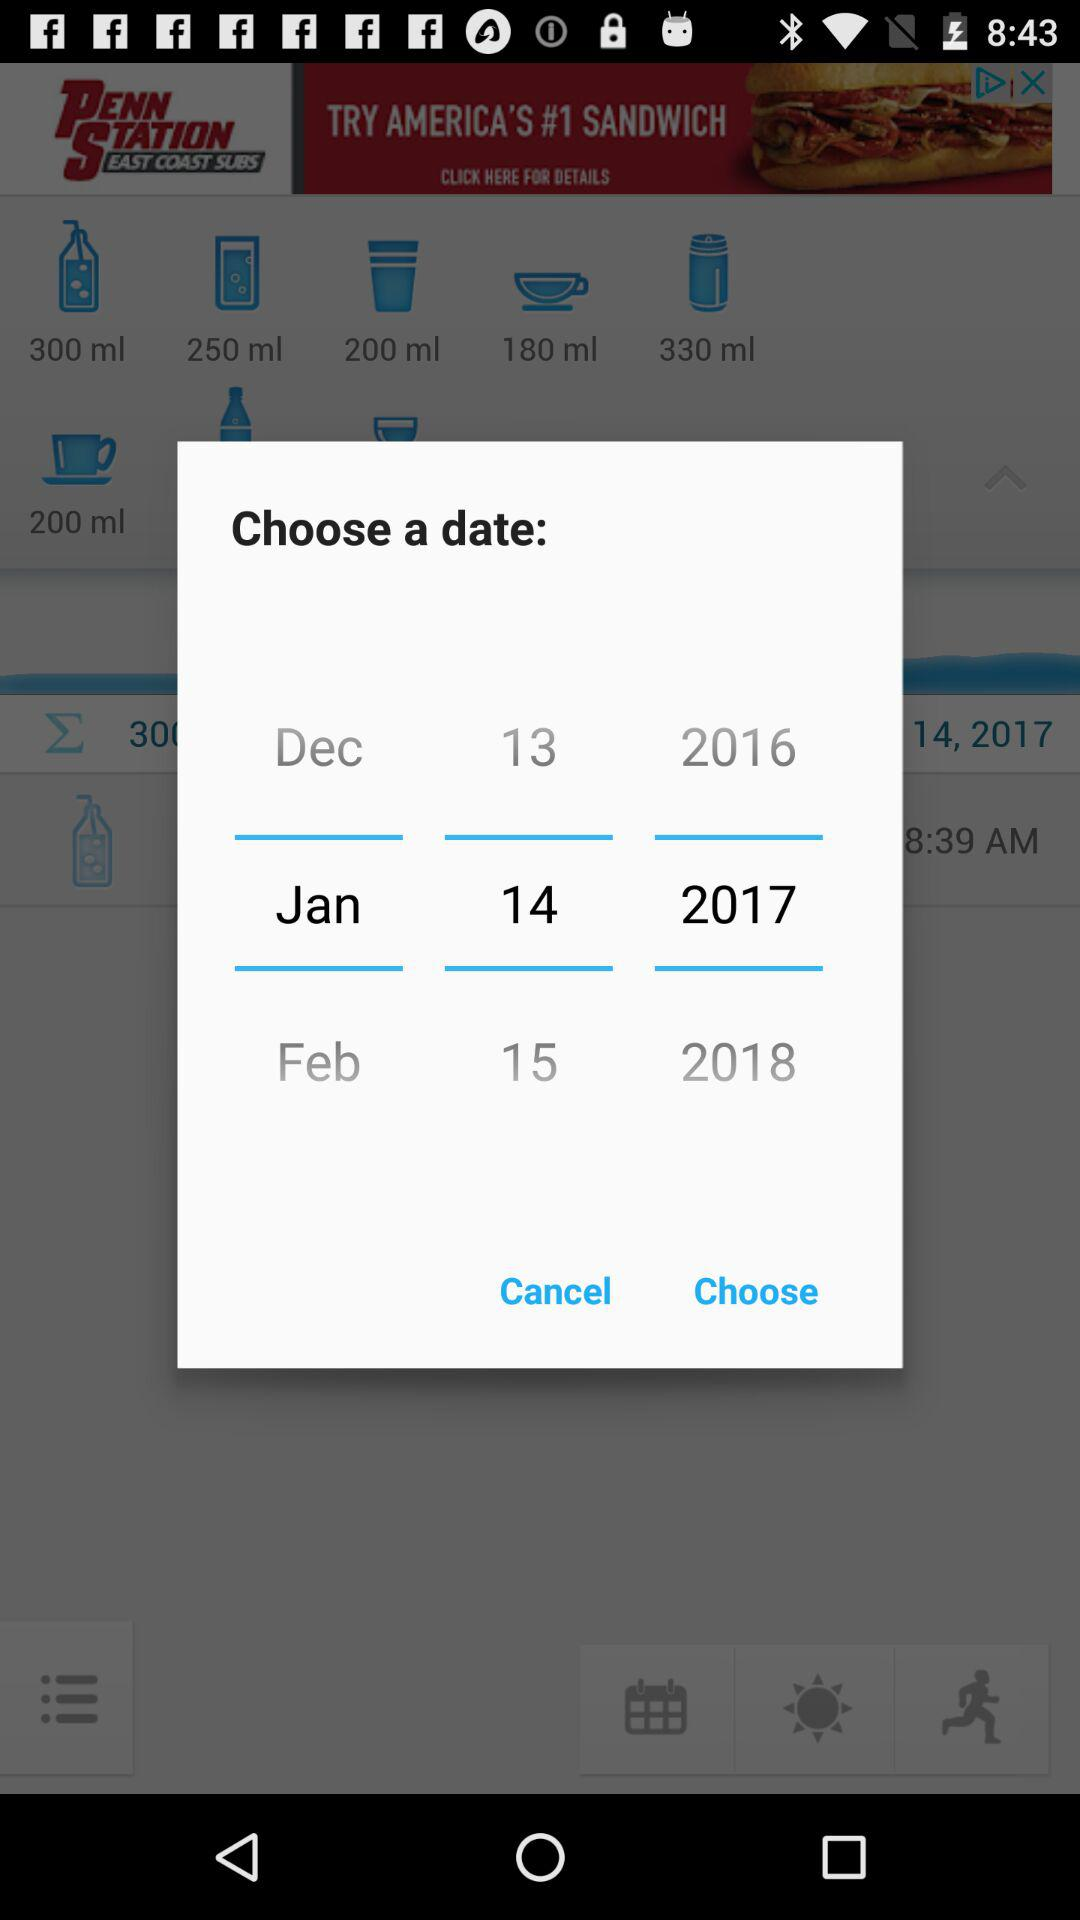How many years are available in the date picker?
Answer the question using a single word or phrase. 3 